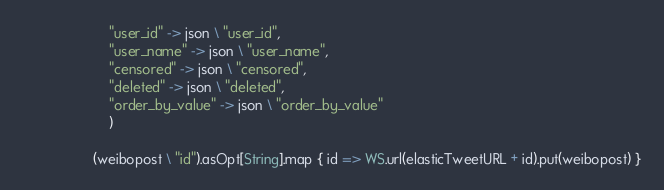<code> <loc_0><loc_0><loc_500><loc_500><_Scala_>                      "user_id" -> json \ "user_id",
                      "user_name" -> json \ "user_name",
                      "censored" -> json \ "censored",
                      "deleted" -> json \ "deleted",
                      "order_by_value" -> json \ "order_by_value"
                      )
  
                  (weibopost \ "id").asOpt[String].map { id => WS.url(elasticTweetURL + id).put(weibopost) }</code> 